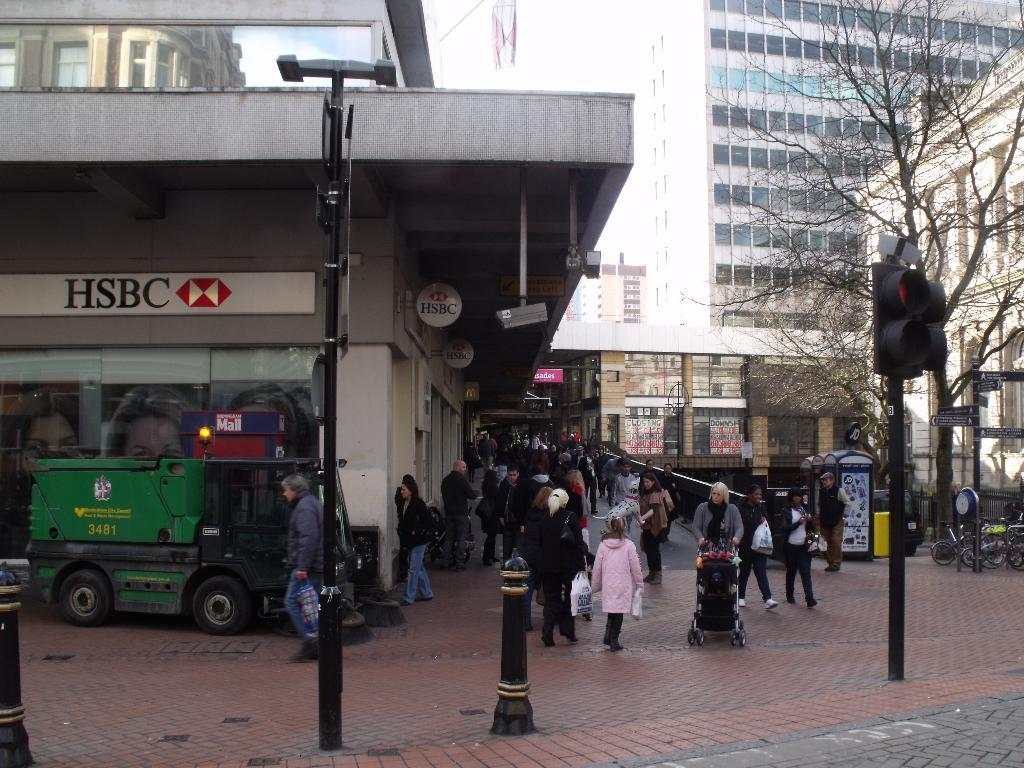What is located at the bottom of the image? There is a crowd at the bottom of the image. What can be seen on the left side of the image? There is a vehicle on the left side of the image. What type of vegetation is on the right side of the image? There are trees on the right side of the image. What is used for controlling traffic on the right side of the image? Signal lights are present on the right side of the image. How many ants can be seen carrying the company's logo in the image? There are no ants or company logos present in the image. What direction is the point facing in the image? There is no point visible in the image. 